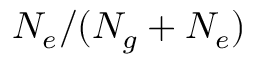Convert formula to latex. <formula><loc_0><loc_0><loc_500><loc_500>N _ { e } / ( N _ { g } + N _ { e } )</formula> 